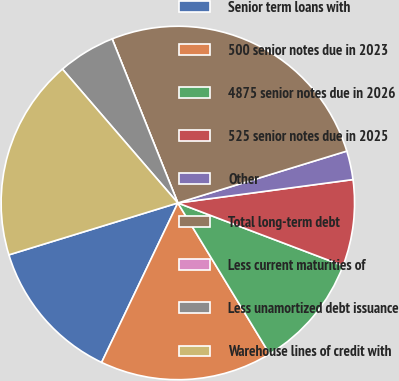Convert chart. <chart><loc_0><loc_0><loc_500><loc_500><pie_chart><fcel>Senior term loans with<fcel>500 senior notes due in 2023<fcel>4875 senior notes due in 2026<fcel>525 senior notes due in 2025<fcel>Other<fcel>Total long-term debt<fcel>Less current maturities of<fcel>Less unamortized debt issuance<fcel>Warehouse lines of credit with<nl><fcel>13.16%<fcel>15.79%<fcel>10.53%<fcel>7.89%<fcel>2.63%<fcel>26.32%<fcel>0.0%<fcel>5.26%<fcel>18.42%<nl></chart> 